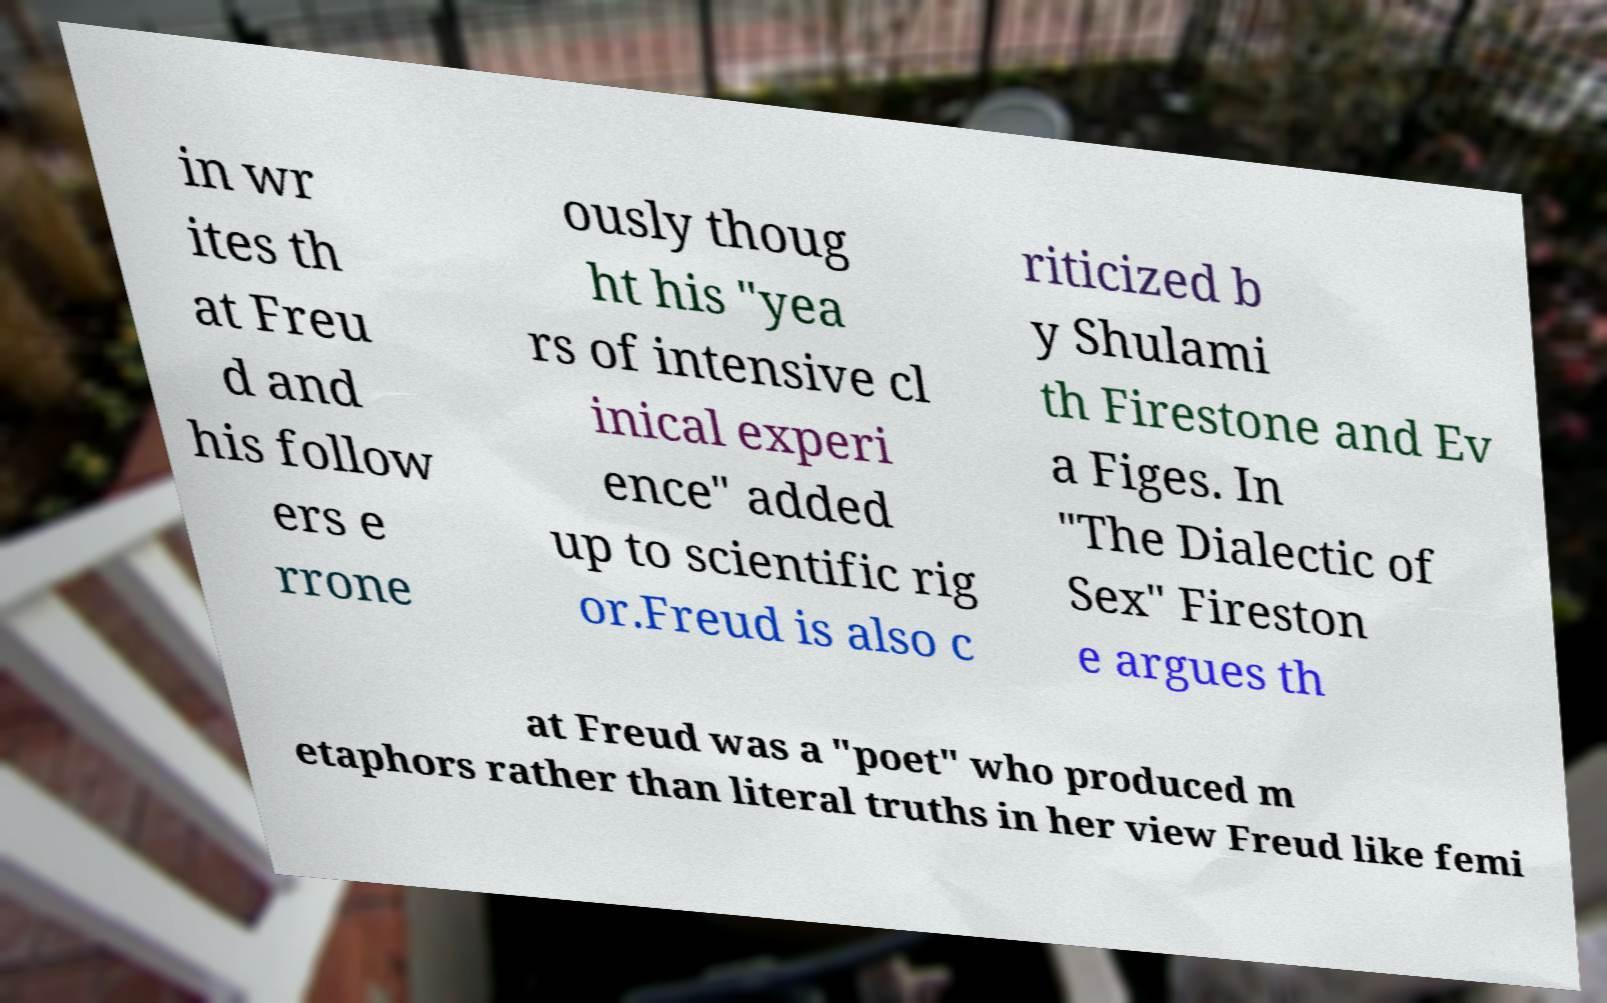There's text embedded in this image that I need extracted. Can you transcribe it verbatim? in wr ites th at Freu d and his follow ers e rrone ously thoug ht his "yea rs of intensive cl inical experi ence" added up to scientific rig or.Freud is also c riticized b y Shulami th Firestone and Ev a Figes. In "The Dialectic of Sex" Fireston e argues th at Freud was a "poet" who produced m etaphors rather than literal truths in her view Freud like femi 